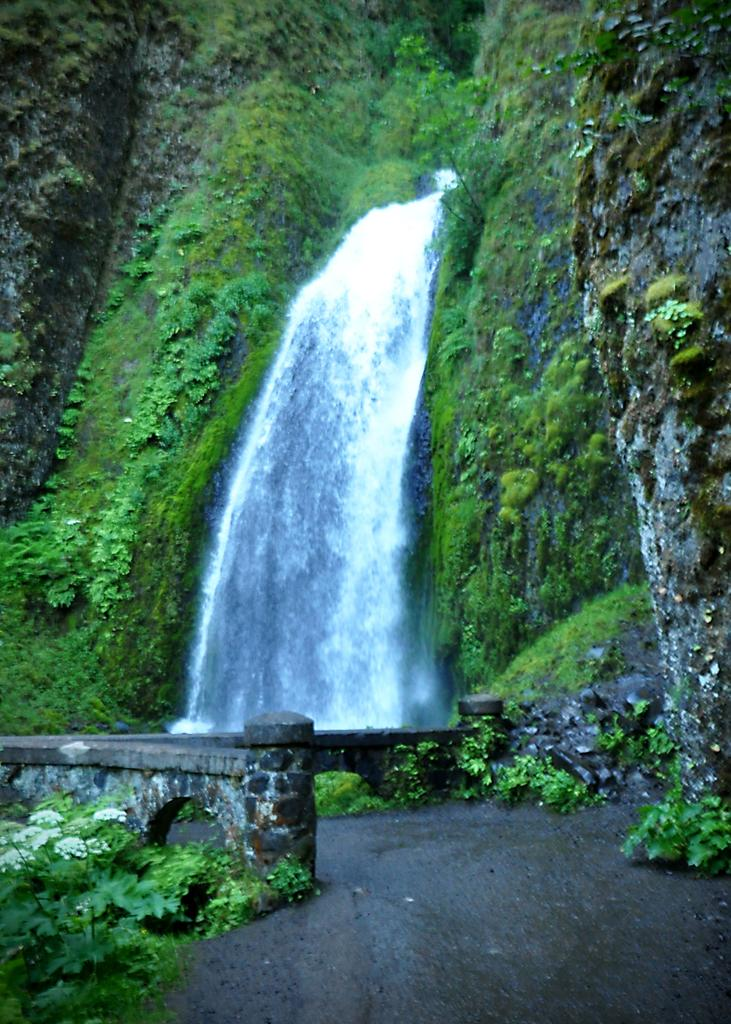What natural feature is the main subject of the image? There is a waterfall in the image. Where is the waterfall located? The waterfall is on a hill. What covers the hill in the image? The hill is covered with plants and algae. What man-made feature is visible in front of the waterfall? There is a road in front of the waterfall. What structure is present along the road? There is a fence along the road. Who is the creator of the rock formation near the waterfall? There is no specific rock formation mentioned in the image, and therefore no creator can be identified. 